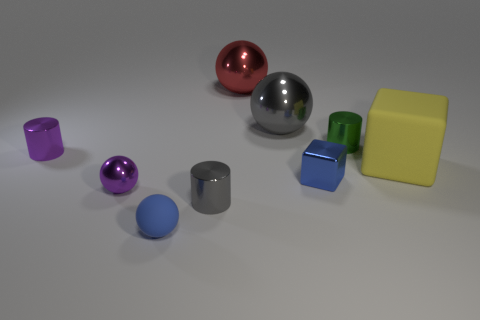Subtract all cubes. How many objects are left? 7 Add 8 tiny yellow rubber spheres. How many tiny yellow rubber spheres exist? 8 Subtract 0 purple blocks. How many objects are left? 9 Subtract all tiny blue rubber things. Subtract all big gray metallic things. How many objects are left? 7 Add 6 tiny purple metallic balls. How many tiny purple metallic balls are left? 7 